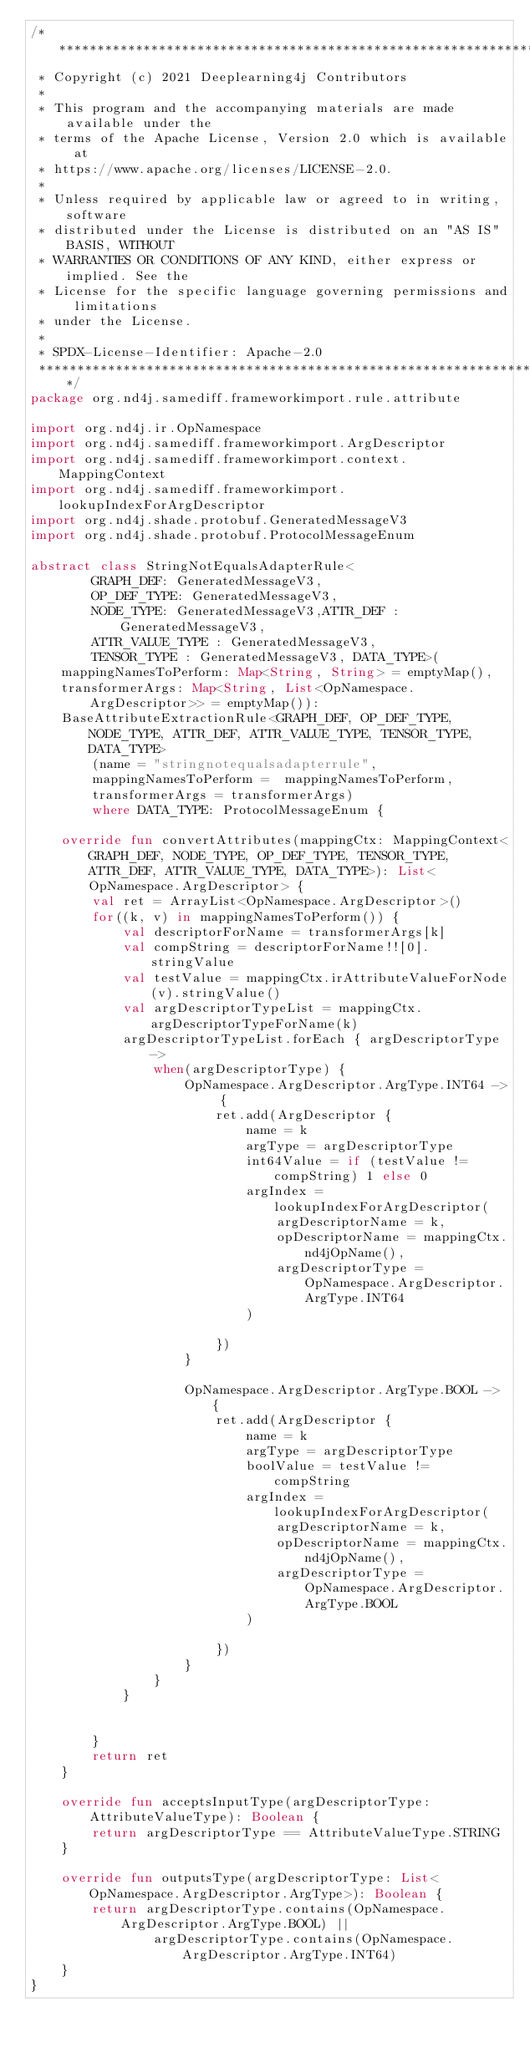Convert code to text. <code><loc_0><loc_0><loc_500><loc_500><_Kotlin_>/* ******************************************************************************
 * Copyright (c) 2021 Deeplearning4j Contributors
 *
 * This program and the accompanying materials are made available under the
 * terms of the Apache License, Version 2.0 which is available at
 * https://www.apache.org/licenses/LICENSE-2.0.
 *
 * Unless required by applicable law or agreed to in writing, software
 * distributed under the License is distributed on an "AS IS" BASIS, WITHOUT
 * WARRANTIES OR CONDITIONS OF ANY KIND, either express or implied. See the
 * License for the specific language governing permissions and limitations
 * under the License.
 *
 * SPDX-License-Identifier: Apache-2.0
 ******************************************************************************/
package org.nd4j.samediff.frameworkimport.rule.attribute

import org.nd4j.ir.OpNamespace
import org.nd4j.samediff.frameworkimport.ArgDescriptor
import org.nd4j.samediff.frameworkimport.context.MappingContext
import org.nd4j.samediff.frameworkimport.lookupIndexForArgDescriptor
import org.nd4j.shade.protobuf.GeneratedMessageV3
import org.nd4j.shade.protobuf.ProtocolMessageEnum

abstract class StringNotEqualsAdapterRule<
        GRAPH_DEF: GeneratedMessageV3,
        OP_DEF_TYPE: GeneratedMessageV3,
        NODE_TYPE: GeneratedMessageV3,ATTR_DEF : GeneratedMessageV3,
        ATTR_VALUE_TYPE : GeneratedMessageV3,
        TENSOR_TYPE : GeneratedMessageV3, DATA_TYPE>(
    mappingNamesToPerform: Map<String, String> = emptyMap(),
    transformerArgs: Map<String, List<OpNamespace.ArgDescriptor>> = emptyMap()):
    BaseAttributeExtractionRule<GRAPH_DEF, OP_DEF_TYPE, NODE_TYPE, ATTR_DEF, ATTR_VALUE_TYPE, TENSOR_TYPE, DATA_TYPE>
        (name = "stringnotequalsadapterrule",
        mappingNamesToPerform =  mappingNamesToPerform,
        transformerArgs = transformerArgs)
        where DATA_TYPE: ProtocolMessageEnum {

    override fun convertAttributes(mappingCtx: MappingContext<GRAPH_DEF, NODE_TYPE, OP_DEF_TYPE, TENSOR_TYPE, ATTR_DEF, ATTR_VALUE_TYPE, DATA_TYPE>): List<OpNamespace.ArgDescriptor> {
        val ret = ArrayList<OpNamespace.ArgDescriptor>()
        for((k, v) in mappingNamesToPerform()) {
            val descriptorForName = transformerArgs[k]
            val compString = descriptorForName!![0].stringValue
            val testValue = mappingCtx.irAttributeValueForNode(v).stringValue()
            val argDescriptorTypeList = mappingCtx.argDescriptorTypeForName(k)
            argDescriptorTypeList.forEach { argDescriptorType ->
                when(argDescriptorType) {
                    OpNamespace.ArgDescriptor.ArgType.INT64 -> {
                        ret.add(ArgDescriptor {
                            name = k
                            argType = argDescriptorType
                            int64Value = if (testValue != compString) 1 else 0
                            argIndex = lookupIndexForArgDescriptor(
                                argDescriptorName = k,
                                opDescriptorName = mappingCtx.nd4jOpName(),
                                argDescriptorType = OpNamespace.ArgDescriptor.ArgType.INT64
                            )

                        })
                    }

                    OpNamespace.ArgDescriptor.ArgType.BOOL -> {
                        ret.add(ArgDescriptor {
                            name = k
                            argType = argDescriptorType
                            boolValue = testValue != compString
                            argIndex = lookupIndexForArgDescriptor(
                                argDescriptorName = k,
                                opDescriptorName = mappingCtx.nd4jOpName(),
                                argDescriptorType = OpNamespace.ArgDescriptor.ArgType.BOOL
                            )

                        })
                    }
                }
            }


        }
        return ret
    }

    override fun acceptsInputType(argDescriptorType: AttributeValueType): Boolean {
        return argDescriptorType == AttributeValueType.STRING
    }

    override fun outputsType(argDescriptorType: List<OpNamespace.ArgDescriptor.ArgType>): Boolean {
        return argDescriptorType.contains(OpNamespace.ArgDescriptor.ArgType.BOOL) ||
                argDescriptorType.contains(OpNamespace.ArgDescriptor.ArgType.INT64)
    }
}</code> 